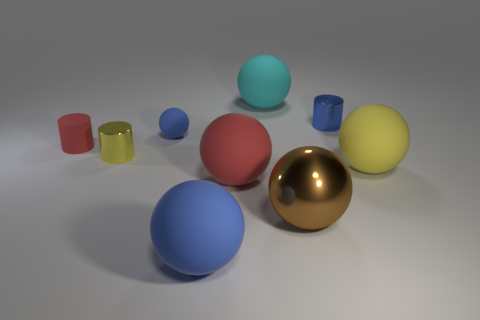What is the large thing that is on the left side of the metallic ball and in front of the big red matte object made of? The large item on the left side of the metallic ball and in front of the big red matte object appears to be a blue sphere that, given the context of the image being a rendering, is likely not made of a real-world material but rather a digitally created surface in a 3D program. The surface might be designed to replicate the look of a plastic or painted wood, based on its smooth and opaque appearance. 